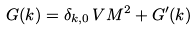Convert formula to latex. <formula><loc_0><loc_0><loc_500><loc_500>G ( { k } ) = \delta _ { { k } , { 0 } } \, V M ^ { 2 } + G ^ { \prime } ( { k } )</formula> 